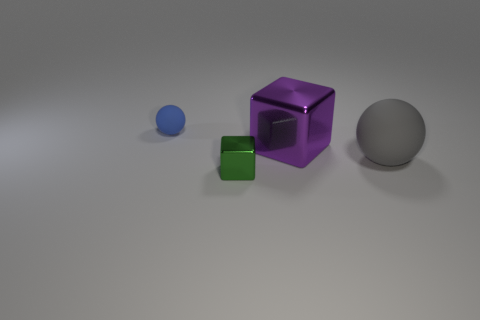How many objects are either rubber spheres to the left of the tiny green shiny block or matte things that are left of the gray sphere?
Offer a very short reply. 1. Do the green metal object and the blue matte ball have the same size?
Your response must be concise. Yes. Is there anything else that has the same size as the purple thing?
Provide a short and direct response. Yes. There is a tiny thing in front of the blue ball; is it the same shape as the tiny thing that is left of the tiny green object?
Keep it short and to the point. No. What is the size of the purple thing?
Provide a succinct answer. Large. What material is the ball left of the metallic cube in front of the metallic object that is behind the tiny green metallic block made of?
Your response must be concise. Rubber. How many other things are the same color as the big metallic cube?
Give a very brief answer. 0. How many cyan things are spheres or big spheres?
Your answer should be compact. 0. What material is the cube on the right side of the green cube?
Your answer should be compact. Metal. Are the sphere that is behind the gray rubber object and the small cube made of the same material?
Your answer should be compact. No. 